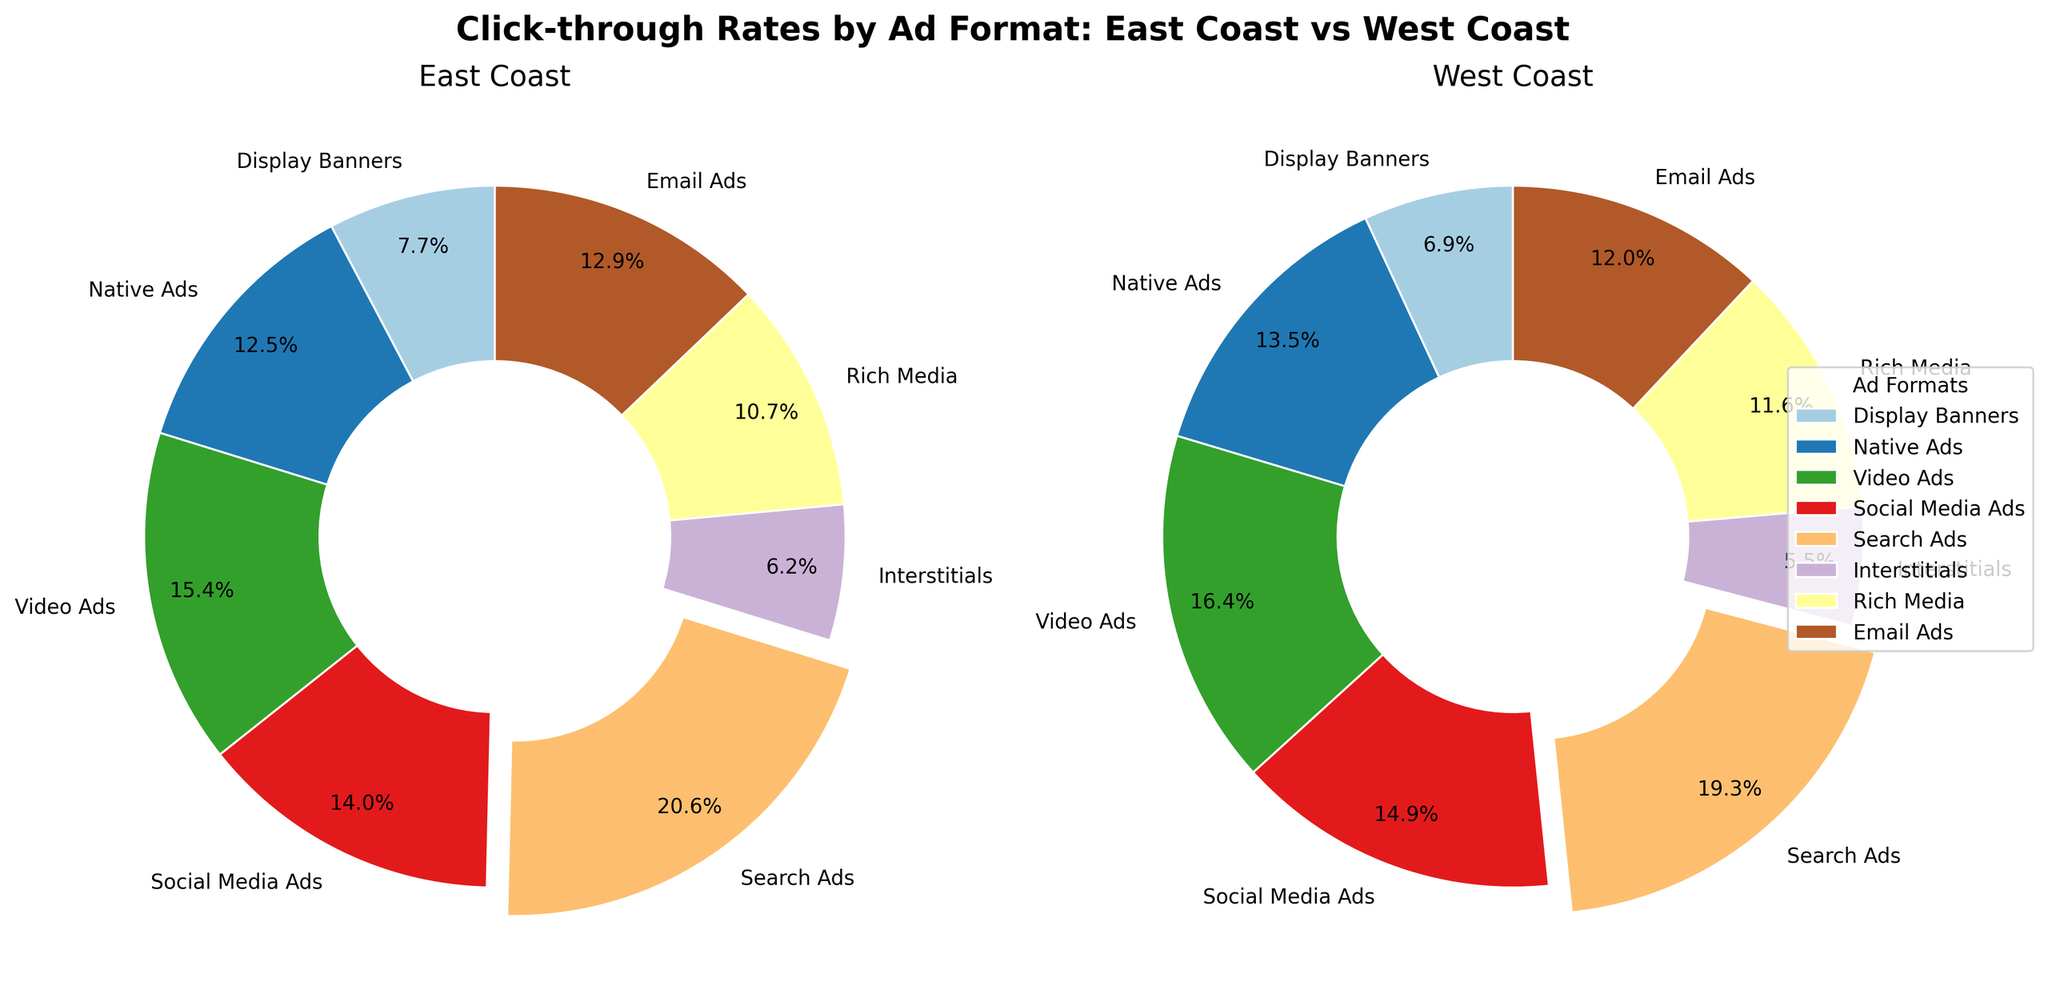What are the two ad formats with the highest CTR on the East Coast and West Coast, respectively? For the East Coast, compare the CTRs for each ad format and identify the highest value. Do the same for the West Coast. On the East Coast, the highest CTR is 5.6% for Search Ads. On the West Coast, the highest CTR is 4.5% for Video Ads.
Answer: East Coast: Search Ads, West Coast: Video Ads Which ad format has a higher CTR on the West Coast compared to the East Coast? Compare the CTRs of each ad format between the East Coast and West Coast. Identify the ad formats where the West Coast CTR is higher than the East Coast CTR. Native Ads, Video Ads, Social Media Ads, Rich Media have higher CTRs on the West Coast.
Answer: Native Ads, Video Ads, Social Media Ads, Rich Media What is the combined percentage of CTR for Social Media Ads and Search Ads on both coasts? Sum the percentages of Social Media Ads and Search Ads for both the East Coast and West Coast: (3.8% + 5.6%) for the East Coast and (4.1% + 5.3%) for the West Coast. 3.8% + 5.6% = 9.4% for East Coast and 4.1% + 5.3% = 9.4% for West Coast.
Answer: East Coast: 9.4%, West Coast: 9.4% Which pie chart (East Coast or West Coast) has an ad format with an exploded slice, and what is that ad format? Identify the pie chart with an exploded slice, which indicates the highest CTR. On the East Coast pie chart, Search Ads have an exploded slice. On the West Coast pie chart, Video Ads have an exploded slice.
Answer: East Coast: Search Ads, West Coast: Video Ads What is the average CTR of Display Banners, Native Ads, and Video Ads on the East Coast? Sum the CTR values for Display Banners (2.1%), Native Ads (3.4%), and Video Ads (4.2%) on the East Coast, then divide by the number of ad formats. (2.1% + 3.4% + 4.2%) / 3 = 9.7% / 3 = 3.23%
Answer: 3.23% Which ad format has the lowest CTR on both coasts? Compare the CTR values for each ad format on both the East Coast and West Coast, and identify the lowest value. The lowest CTR on both coasts is for Interstitials.
Answer: Interstitials Is the percentage of Email Ads higher on the East Coast or West Coast? Compare the CTR values of Email Ads between the East Coast (3.5%) and the West Coast (3.3%). The CTR for Email Ads is higher on the East Coast.
Answer: East Coast What is the difference in CTR for Search Ads between the East Coast and West Coast? Subtract the West Coast CTR for Search Ads (5.3%) from the East Coast CTR for Search Ads (5.6%). 5.6% - 5.3% = 0.3%
Answer: 0.3% What is the combined total CTR for Native Ads and Video Ads on the West Coast? Sum the CTR values for Native Ads (3.7%) and Video Ads (4.5%) on the West Coast. 3.7% + 4.5% = 8.2%
Answer: 8.2% Which ad format appears fourth in terms of East Coast CTR? Arrange the ad formats by their CTR values on the East Coast in descending order and identify the fourth one. The ad formats in descending order are Search Ads (5.6%), Video Ads (4.2%), Social Media Ads (3.8%), and Email Ads (3.5%).
Answer: Email Ads 